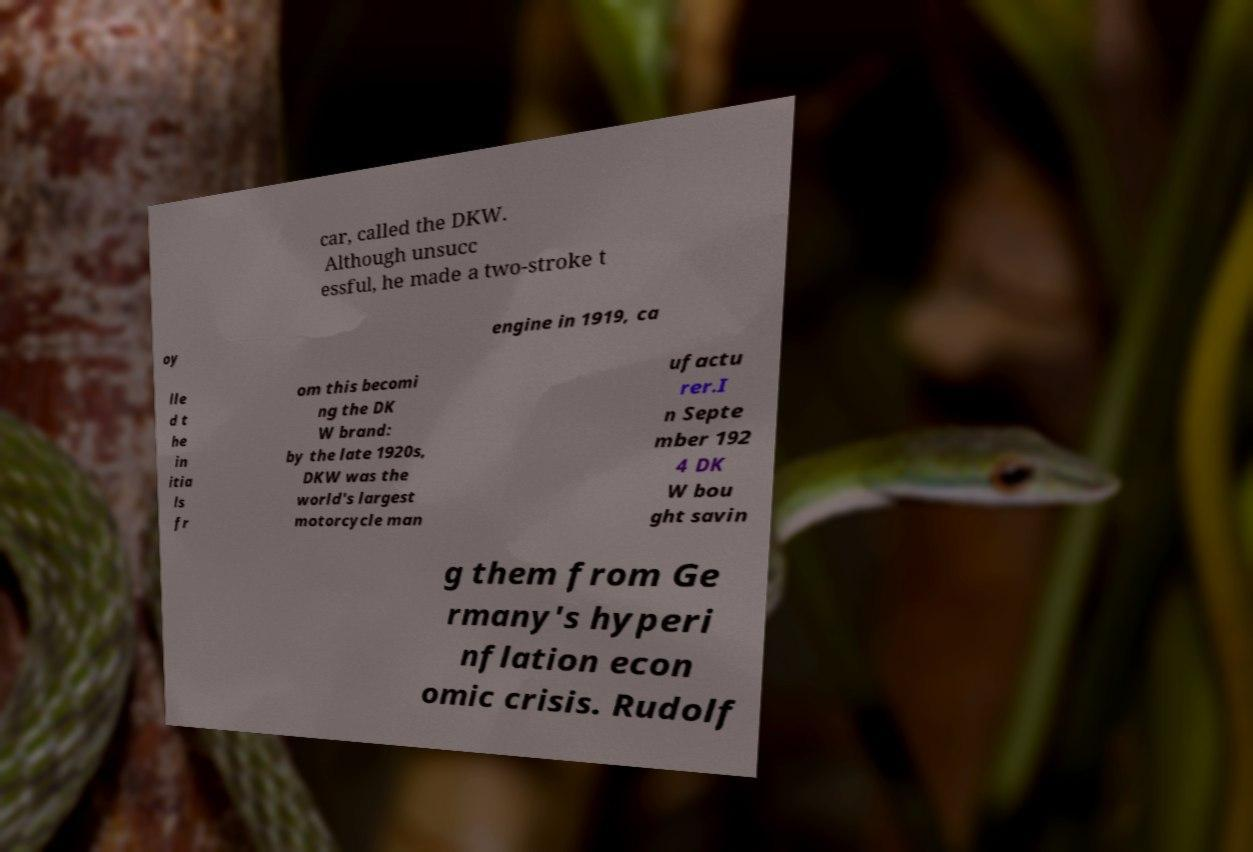Could you assist in decoding the text presented in this image and type it out clearly? car, called the DKW. Although unsucc essful, he made a two-stroke t oy engine in 1919, ca lle d t he in itia ls fr om this becomi ng the DK W brand: by the late 1920s, DKW was the world's largest motorcycle man ufactu rer.I n Septe mber 192 4 DK W bou ght savin g them from Ge rmany's hyperi nflation econ omic crisis. Rudolf 